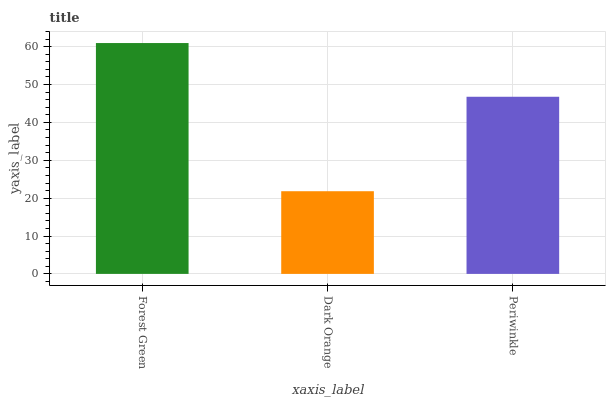Is Dark Orange the minimum?
Answer yes or no. Yes. Is Forest Green the maximum?
Answer yes or no. Yes. Is Periwinkle the minimum?
Answer yes or no. No. Is Periwinkle the maximum?
Answer yes or no. No. Is Periwinkle greater than Dark Orange?
Answer yes or no. Yes. Is Dark Orange less than Periwinkle?
Answer yes or no. Yes. Is Dark Orange greater than Periwinkle?
Answer yes or no. No. Is Periwinkle less than Dark Orange?
Answer yes or no. No. Is Periwinkle the high median?
Answer yes or no. Yes. Is Periwinkle the low median?
Answer yes or no. Yes. Is Forest Green the high median?
Answer yes or no. No. Is Forest Green the low median?
Answer yes or no. No. 